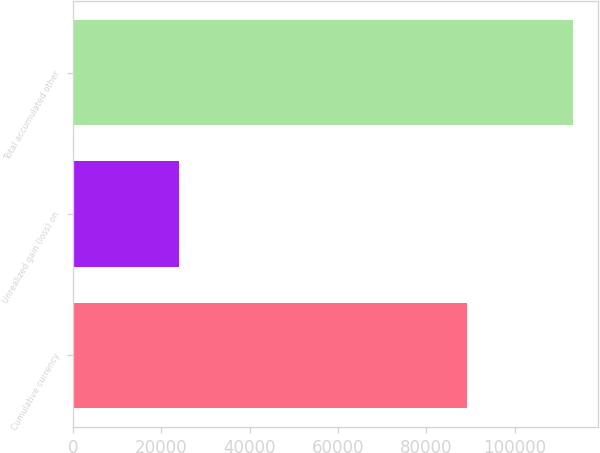Convert chart to OTSL. <chart><loc_0><loc_0><loc_500><loc_500><bar_chart><fcel>Cumulative currency<fcel>Unrealized gain (loss) on<fcel>Total accumulated other<nl><fcel>89289<fcel>23888<fcel>113177<nl></chart> 